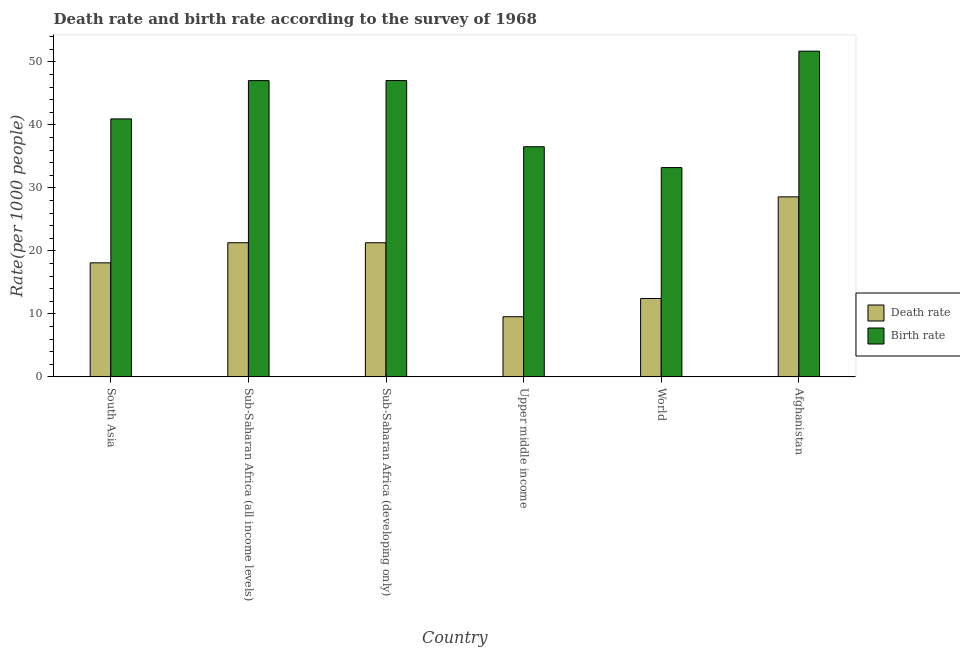Are the number of bars on each tick of the X-axis equal?
Give a very brief answer. Yes. How many bars are there on the 6th tick from the left?
Your answer should be compact. 2. How many bars are there on the 6th tick from the right?
Give a very brief answer. 2. What is the label of the 6th group of bars from the left?
Provide a short and direct response. Afghanistan. In how many cases, is the number of bars for a given country not equal to the number of legend labels?
Provide a succinct answer. 0. What is the death rate in Sub-Saharan Africa (developing only)?
Keep it short and to the point. 21.29. Across all countries, what is the maximum birth rate?
Provide a succinct answer. 51.7. Across all countries, what is the minimum death rate?
Ensure brevity in your answer.  9.55. In which country was the birth rate maximum?
Make the answer very short. Afghanistan. In which country was the death rate minimum?
Make the answer very short. Upper middle income. What is the total death rate in the graph?
Offer a terse response. 111.25. What is the difference between the death rate in Sub-Saharan Africa (all income levels) and that in Upper middle income?
Give a very brief answer. 11.75. What is the difference between the death rate in South Asia and the birth rate in World?
Make the answer very short. -15.12. What is the average birth rate per country?
Keep it short and to the point. 42.75. What is the difference between the birth rate and death rate in South Asia?
Offer a very short reply. 22.85. In how many countries, is the death rate greater than 40 ?
Offer a very short reply. 0. What is the ratio of the birth rate in Sub-Saharan Africa (all income levels) to that in Upper middle income?
Give a very brief answer. 1.29. Is the difference between the death rate in Sub-Saharan Africa (developing only) and Upper middle income greater than the difference between the birth rate in Sub-Saharan Africa (developing only) and Upper middle income?
Your response must be concise. Yes. What is the difference between the highest and the second highest death rate?
Provide a short and direct response. 7.28. What is the difference between the highest and the lowest birth rate?
Give a very brief answer. 18.48. What does the 2nd bar from the left in Sub-Saharan Africa (developing only) represents?
Make the answer very short. Birth rate. What does the 2nd bar from the right in Upper middle income represents?
Provide a succinct answer. Death rate. How many bars are there?
Your answer should be very brief. 12. Are all the bars in the graph horizontal?
Keep it short and to the point. No. How many countries are there in the graph?
Make the answer very short. 6. What is the difference between two consecutive major ticks on the Y-axis?
Ensure brevity in your answer.  10. Does the graph contain any zero values?
Give a very brief answer. No. Does the graph contain grids?
Keep it short and to the point. No. Where does the legend appear in the graph?
Offer a terse response. Center right. How many legend labels are there?
Your response must be concise. 2. What is the title of the graph?
Provide a short and direct response. Death rate and birth rate according to the survey of 1968. Does "RDB concessional" appear as one of the legend labels in the graph?
Give a very brief answer. No. What is the label or title of the X-axis?
Provide a short and direct response. Country. What is the label or title of the Y-axis?
Provide a short and direct response. Rate(per 1000 people). What is the Rate(per 1000 people) of Death rate in South Asia?
Offer a very short reply. 18.1. What is the Rate(per 1000 people) of Birth rate in South Asia?
Your response must be concise. 40.95. What is the Rate(per 1000 people) in Death rate in Sub-Saharan Africa (all income levels)?
Give a very brief answer. 21.29. What is the Rate(per 1000 people) of Birth rate in Sub-Saharan Africa (all income levels)?
Provide a short and direct response. 47.03. What is the Rate(per 1000 people) of Death rate in Sub-Saharan Africa (developing only)?
Keep it short and to the point. 21.29. What is the Rate(per 1000 people) of Birth rate in Sub-Saharan Africa (developing only)?
Provide a succinct answer. 47.04. What is the Rate(per 1000 people) of Death rate in Upper middle income?
Make the answer very short. 9.55. What is the Rate(per 1000 people) of Birth rate in Upper middle income?
Provide a short and direct response. 36.53. What is the Rate(per 1000 people) in Death rate in World?
Your response must be concise. 12.44. What is the Rate(per 1000 people) in Birth rate in World?
Provide a succinct answer. 33.22. What is the Rate(per 1000 people) in Death rate in Afghanistan?
Offer a very short reply. 28.58. What is the Rate(per 1000 people) in Birth rate in Afghanistan?
Provide a succinct answer. 51.7. Across all countries, what is the maximum Rate(per 1000 people) of Death rate?
Your response must be concise. 28.58. Across all countries, what is the maximum Rate(per 1000 people) of Birth rate?
Keep it short and to the point. 51.7. Across all countries, what is the minimum Rate(per 1000 people) of Death rate?
Give a very brief answer. 9.55. Across all countries, what is the minimum Rate(per 1000 people) of Birth rate?
Make the answer very short. 33.22. What is the total Rate(per 1000 people) in Death rate in the graph?
Provide a short and direct response. 111.25. What is the total Rate(per 1000 people) of Birth rate in the graph?
Offer a very short reply. 256.48. What is the difference between the Rate(per 1000 people) in Death rate in South Asia and that in Sub-Saharan Africa (all income levels)?
Your answer should be very brief. -3.19. What is the difference between the Rate(per 1000 people) of Birth rate in South Asia and that in Sub-Saharan Africa (all income levels)?
Ensure brevity in your answer.  -6.08. What is the difference between the Rate(per 1000 people) in Death rate in South Asia and that in Sub-Saharan Africa (developing only)?
Offer a terse response. -3.19. What is the difference between the Rate(per 1000 people) in Birth rate in South Asia and that in Sub-Saharan Africa (developing only)?
Offer a very short reply. -6.09. What is the difference between the Rate(per 1000 people) in Death rate in South Asia and that in Upper middle income?
Give a very brief answer. 8.55. What is the difference between the Rate(per 1000 people) of Birth rate in South Asia and that in Upper middle income?
Keep it short and to the point. 4.42. What is the difference between the Rate(per 1000 people) of Death rate in South Asia and that in World?
Ensure brevity in your answer.  5.66. What is the difference between the Rate(per 1000 people) of Birth rate in South Asia and that in World?
Your response must be concise. 7.73. What is the difference between the Rate(per 1000 people) in Death rate in South Asia and that in Afghanistan?
Make the answer very short. -10.47. What is the difference between the Rate(per 1000 people) in Birth rate in South Asia and that in Afghanistan?
Provide a succinct answer. -10.75. What is the difference between the Rate(per 1000 people) of Death rate in Sub-Saharan Africa (all income levels) and that in Sub-Saharan Africa (developing only)?
Make the answer very short. 0. What is the difference between the Rate(per 1000 people) in Birth rate in Sub-Saharan Africa (all income levels) and that in Sub-Saharan Africa (developing only)?
Provide a succinct answer. -0.01. What is the difference between the Rate(per 1000 people) in Death rate in Sub-Saharan Africa (all income levels) and that in Upper middle income?
Keep it short and to the point. 11.75. What is the difference between the Rate(per 1000 people) in Birth rate in Sub-Saharan Africa (all income levels) and that in Upper middle income?
Your response must be concise. 10.5. What is the difference between the Rate(per 1000 people) of Death rate in Sub-Saharan Africa (all income levels) and that in World?
Give a very brief answer. 8.85. What is the difference between the Rate(per 1000 people) of Birth rate in Sub-Saharan Africa (all income levels) and that in World?
Your response must be concise. 13.81. What is the difference between the Rate(per 1000 people) of Death rate in Sub-Saharan Africa (all income levels) and that in Afghanistan?
Your response must be concise. -7.28. What is the difference between the Rate(per 1000 people) in Birth rate in Sub-Saharan Africa (all income levels) and that in Afghanistan?
Your response must be concise. -4.67. What is the difference between the Rate(per 1000 people) in Death rate in Sub-Saharan Africa (developing only) and that in Upper middle income?
Provide a short and direct response. 11.74. What is the difference between the Rate(per 1000 people) of Birth rate in Sub-Saharan Africa (developing only) and that in Upper middle income?
Your answer should be compact. 10.51. What is the difference between the Rate(per 1000 people) in Death rate in Sub-Saharan Africa (developing only) and that in World?
Ensure brevity in your answer.  8.85. What is the difference between the Rate(per 1000 people) in Birth rate in Sub-Saharan Africa (developing only) and that in World?
Offer a very short reply. 13.81. What is the difference between the Rate(per 1000 people) in Death rate in Sub-Saharan Africa (developing only) and that in Afghanistan?
Offer a very short reply. -7.29. What is the difference between the Rate(per 1000 people) in Birth rate in Sub-Saharan Africa (developing only) and that in Afghanistan?
Your response must be concise. -4.67. What is the difference between the Rate(per 1000 people) of Death rate in Upper middle income and that in World?
Your answer should be very brief. -2.89. What is the difference between the Rate(per 1000 people) in Birth rate in Upper middle income and that in World?
Your response must be concise. 3.31. What is the difference between the Rate(per 1000 people) in Death rate in Upper middle income and that in Afghanistan?
Offer a very short reply. -19.03. What is the difference between the Rate(per 1000 people) in Birth rate in Upper middle income and that in Afghanistan?
Keep it short and to the point. -15.17. What is the difference between the Rate(per 1000 people) of Death rate in World and that in Afghanistan?
Ensure brevity in your answer.  -16.14. What is the difference between the Rate(per 1000 people) in Birth rate in World and that in Afghanistan?
Ensure brevity in your answer.  -18.48. What is the difference between the Rate(per 1000 people) of Death rate in South Asia and the Rate(per 1000 people) of Birth rate in Sub-Saharan Africa (all income levels)?
Provide a succinct answer. -28.93. What is the difference between the Rate(per 1000 people) in Death rate in South Asia and the Rate(per 1000 people) in Birth rate in Sub-Saharan Africa (developing only)?
Offer a very short reply. -28.94. What is the difference between the Rate(per 1000 people) in Death rate in South Asia and the Rate(per 1000 people) in Birth rate in Upper middle income?
Your answer should be compact. -18.43. What is the difference between the Rate(per 1000 people) in Death rate in South Asia and the Rate(per 1000 people) in Birth rate in World?
Your answer should be compact. -15.12. What is the difference between the Rate(per 1000 people) of Death rate in South Asia and the Rate(per 1000 people) of Birth rate in Afghanistan?
Provide a short and direct response. -33.6. What is the difference between the Rate(per 1000 people) in Death rate in Sub-Saharan Africa (all income levels) and the Rate(per 1000 people) in Birth rate in Sub-Saharan Africa (developing only)?
Keep it short and to the point. -25.75. What is the difference between the Rate(per 1000 people) in Death rate in Sub-Saharan Africa (all income levels) and the Rate(per 1000 people) in Birth rate in Upper middle income?
Provide a short and direct response. -15.24. What is the difference between the Rate(per 1000 people) in Death rate in Sub-Saharan Africa (all income levels) and the Rate(per 1000 people) in Birth rate in World?
Make the answer very short. -11.93. What is the difference between the Rate(per 1000 people) in Death rate in Sub-Saharan Africa (all income levels) and the Rate(per 1000 people) in Birth rate in Afghanistan?
Your answer should be very brief. -30.41. What is the difference between the Rate(per 1000 people) in Death rate in Sub-Saharan Africa (developing only) and the Rate(per 1000 people) in Birth rate in Upper middle income?
Make the answer very short. -15.24. What is the difference between the Rate(per 1000 people) of Death rate in Sub-Saharan Africa (developing only) and the Rate(per 1000 people) of Birth rate in World?
Offer a very short reply. -11.94. What is the difference between the Rate(per 1000 people) in Death rate in Sub-Saharan Africa (developing only) and the Rate(per 1000 people) in Birth rate in Afghanistan?
Your answer should be very brief. -30.42. What is the difference between the Rate(per 1000 people) in Death rate in Upper middle income and the Rate(per 1000 people) in Birth rate in World?
Give a very brief answer. -23.68. What is the difference between the Rate(per 1000 people) in Death rate in Upper middle income and the Rate(per 1000 people) in Birth rate in Afghanistan?
Give a very brief answer. -42.16. What is the difference between the Rate(per 1000 people) in Death rate in World and the Rate(per 1000 people) in Birth rate in Afghanistan?
Your response must be concise. -39.26. What is the average Rate(per 1000 people) in Death rate per country?
Make the answer very short. 18.54. What is the average Rate(per 1000 people) in Birth rate per country?
Give a very brief answer. 42.75. What is the difference between the Rate(per 1000 people) of Death rate and Rate(per 1000 people) of Birth rate in South Asia?
Your response must be concise. -22.85. What is the difference between the Rate(per 1000 people) in Death rate and Rate(per 1000 people) in Birth rate in Sub-Saharan Africa (all income levels)?
Offer a terse response. -25.74. What is the difference between the Rate(per 1000 people) of Death rate and Rate(per 1000 people) of Birth rate in Sub-Saharan Africa (developing only)?
Offer a terse response. -25.75. What is the difference between the Rate(per 1000 people) in Death rate and Rate(per 1000 people) in Birth rate in Upper middle income?
Your response must be concise. -26.98. What is the difference between the Rate(per 1000 people) in Death rate and Rate(per 1000 people) in Birth rate in World?
Provide a short and direct response. -20.78. What is the difference between the Rate(per 1000 people) in Death rate and Rate(per 1000 people) in Birth rate in Afghanistan?
Give a very brief answer. -23.13. What is the ratio of the Rate(per 1000 people) in Death rate in South Asia to that in Sub-Saharan Africa (all income levels)?
Offer a terse response. 0.85. What is the ratio of the Rate(per 1000 people) of Birth rate in South Asia to that in Sub-Saharan Africa (all income levels)?
Keep it short and to the point. 0.87. What is the ratio of the Rate(per 1000 people) in Death rate in South Asia to that in Sub-Saharan Africa (developing only)?
Offer a very short reply. 0.85. What is the ratio of the Rate(per 1000 people) in Birth rate in South Asia to that in Sub-Saharan Africa (developing only)?
Offer a very short reply. 0.87. What is the ratio of the Rate(per 1000 people) in Death rate in South Asia to that in Upper middle income?
Your response must be concise. 1.9. What is the ratio of the Rate(per 1000 people) of Birth rate in South Asia to that in Upper middle income?
Your answer should be compact. 1.12. What is the ratio of the Rate(per 1000 people) in Death rate in South Asia to that in World?
Give a very brief answer. 1.46. What is the ratio of the Rate(per 1000 people) in Birth rate in South Asia to that in World?
Offer a terse response. 1.23. What is the ratio of the Rate(per 1000 people) of Death rate in South Asia to that in Afghanistan?
Offer a terse response. 0.63. What is the ratio of the Rate(per 1000 people) in Birth rate in South Asia to that in Afghanistan?
Your answer should be compact. 0.79. What is the ratio of the Rate(per 1000 people) of Death rate in Sub-Saharan Africa (all income levels) to that in Sub-Saharan Africa (developing only)?
Offer a terse response. 1. What is the ratio of the Rate(per 1000 people) of Death rate in Sub-Saharan Africa (all income levels) to that in Upper middle income?
Your response must be concise. 2.23. What is the ratio of the Rate(per 1000 people) of Birth rate in Sub-Saharan Africa (all income levels) to that in Upper middle income?
Your answer should be compact. 1.29. What is the ratio of the Rate(per 1000 people) of Death rate in Sub-Saharan Africa (all income levels) to that in World?
Make the answer very short. 1.71. What is the ratio of the Rate(per 1000 people) in Birth rate in Sub-Saharan Africa (all income levels) to that in World?
Your response must be concise. 1.42. What is the ratio of the Rate(per 1000 people) in Death rate in Sub-Saharan Africa (all income levels) to that in Afghanistan?
Offer a very short reply. 0.75. What is the ratio of the Rate(per 1000 people) in Birth rate in Sub-Saharan Africa (all income levels) to that in Afghanistan?
Offer a terse response. 0.91. What is the ratio of the Rate(per 1000 people) in Death rate in Sub-Saharan Africa (developing only) to that in Upper middle income?
Keep it short and to the point. 2.23. What is the ratio of the Rate(per 1000 people) of Birth rate in Sub-Saharan Africa (developing only) to that in Upper middle income?
Provide a succinct answer. 1.29. What is the ratio of the Rate(per 1000 people) in Death rate in Sub-Saharan Africa (developing only) to that in World?
Your answer should be very brief. 1.71. What is the ratio of the Rate(per 1000 people) of Birth rate in Sub-Saharan Africa (developing only) to that in World?
Provide a short and direct response. 1.42. What is the ratio of the Rate(per 1000 people) in Death rate in Sub-Saharan Africa (developing only) to that in Afghanistan?
Give a very brief answer. 0.74. What is the ratio of the Rate(per 1000 people) of Birth rate in Sub-Saharan Africa (developing only) to that in Afghanistan?
Your response must be concise. 0.91. What is the ratio of the Rate(per 1000 people) in Death rate in Upper middle income to that in World?
Provide a succinct answer. 0.77. What is the ratio of the Rate(per 1000 people) in Birth rate in Upper middle income to that in World?
Your answer should be compact. 1.1. What is the ratio of the Rate(per 1000 people) in Death rate in Upper middle income to that in Afghanistan?
Ensure brevity in your answer.  0.33. What is the ratio of the Rate(per 1000 people) in Birth rate in Upper middle income to that in Afghanistan?
Offer a very short reply. 0.71. What is the ratio of the Rate(per 1000 people) of Death rate in World to that in Afghanistan?
Make the answer very short. 0.44. What is the ratio of the Rate(per 1000 people) of Birth rate in World to that in Afghanistan?
Your response must be concise. 0.64. What is the difference between the highest and the second highest Rate(per 1000 people) in Death rate?
Offer a very short reply. 7.28. What is the difference between the highest and the second highest Rate(per 1000 people) in Birth rate?
Keep it short and to the point. 4.67. What is the difference between the highest and the lowest Rate(per 1000 people) of Death rate?
Your answer should be compact. 19.03. What is the difference between the highest and the lowest Rate(per 1000 people) of Birth rate?
Make the answer very short. 18.48. 